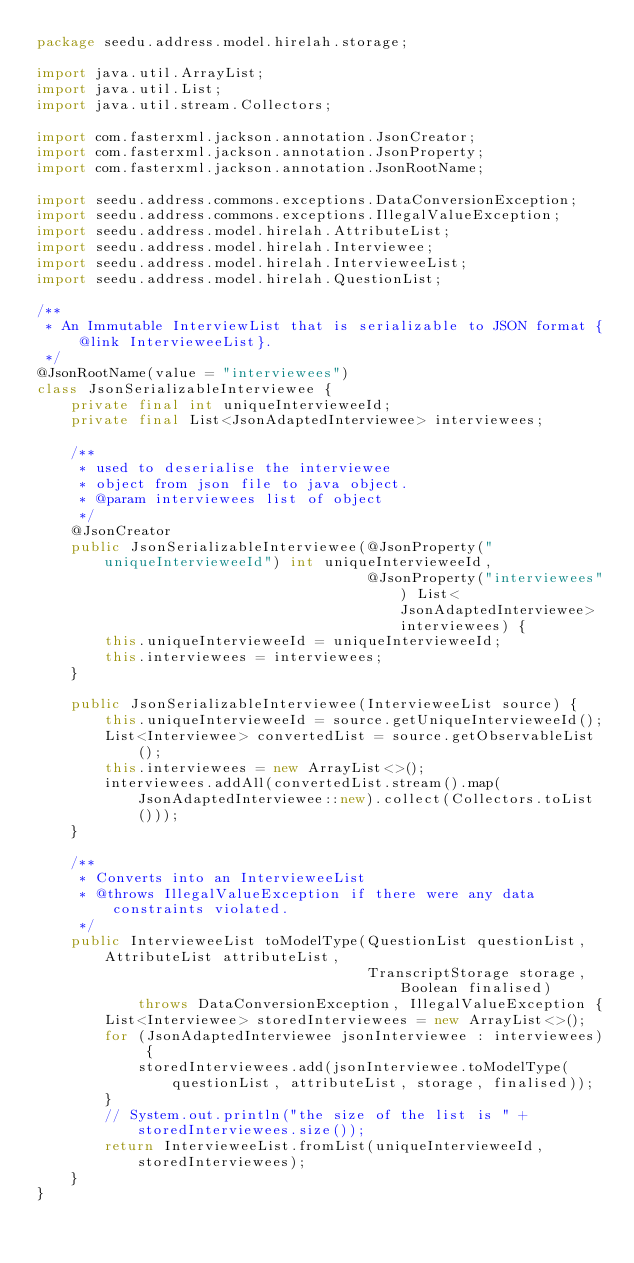Convert code to text. <code><loc_0><loc_0><loc_500><loc_500><_Java_>package seedu.address.model.hirelah.storage;

import java.util.ArrayList;
import java.util.List;
import java.util.stream.Collectors;

import com.fasterxml.jackson.annotation.JsonCreator;
import com.fasterxml.jackson.annotation.JsonProperty;
import com.fasterxml.jackson.annotation.JsonRootName;

import seedu.address.commons.exceptions.DataConversionException;
import seedu.address.commons.exceptions.IllegalValueException;
import seedu.address.model.hirelah.AttributeList;
import seedu.address.model.hirelah.Interviewee;
import seedu.address.model.hirelah.IntervieweeList;
import seedu.address.model.hirelah.QuestionList;

/**
 * An Immutable InterviewList that is serializable to JSON format {@link IntervieweeList}.
 */
@JsonRootName(value = "interviewees")
class JsonSerializableInterviewee {
    private final int uniqueIntervieweeId;
    private final List<JsonAdaptedInterviewee> interviewees;

    /**
     * used to deserialise the interviewee
     * object from json file to java object.
     * @param interviewees list of object
     */
    @JsonCreator
    public JsonSerializableInterviewee(@JsonProperty("uniqueIntervieweeId") int uniqueIntervieweeId,
                                       @JsonProperty("interviewees") List<JsonAdaptedInterviewee> interviewees) {
        this.uniqueIntervieweeId = uniqueIntervieweeId;
        this.interviewees = interviewees;
    }

    public JsonSerializableInterviewee(IntervieweeList source) {
        this.uniqueIntervieweeId = source.getUniqueIntervieweeId();
        List<Interviewee> convertedList = source.getObservableList();
        this.interviewees = new ArrayList<>();
        interviewees.addAll(convertedList.stream().map(JsonAdaptedInterviewee::new).collect(Collectors.toList()));
    }

    /**
     * Converts into an IntervieweeList
     * @throws IllegalValueException if there were any data constraints violated.
     */
    public IntervieweeList toModelType(QuestionList questionList, AttributeList attributeList,
                                       TranscriptStorage storage, Boolean finalised)
            throws DataConversionException, IllegalValueException {
        List<Interviewee> storedInterviewees = new ArrayList<>();
        for (JsonAdaptedInterviewee jsonInterviewee : interviewees) {
            storedInterviewees.add(jsonInterviewee.toModelType(questionList, attributeList, storage, finalised));
        }
        // System.out.println("the size of the list is " + storedInterviewees.size());
        return IntervieweeList.fromList(uniqueIntervieweeId, storedInterviewees);
    }
}
</code> 